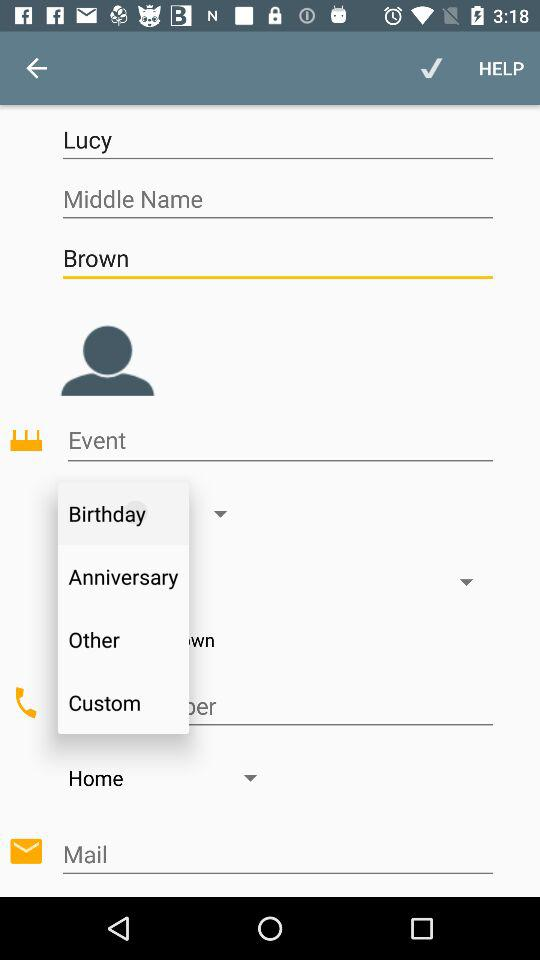What is the first name? The first name is Lucy. 